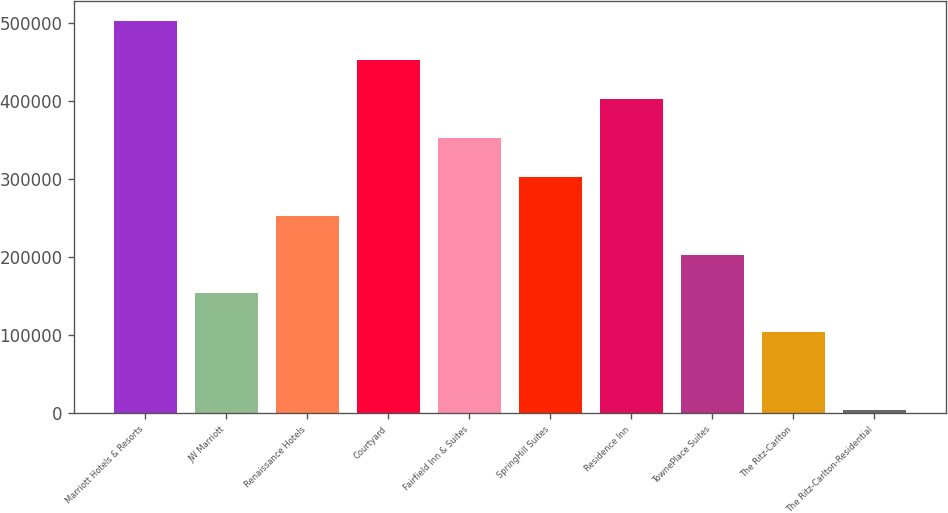Convert chart. <chart><loc_0><loc_0><loc_500><loc_500><bar_chart><fcel>Marriott Hotels & Resorts<fcel>JW Marriott<fcel>Renaissance Hotels<fcel>Courtyard<fcel>Fairfield Inn & Suites<fcel>SpringHill Suites<fcel>Residence Inn<fcel>TownePlace Suites<fcel>The Ritz-Carlton<fcel>The Ritz-Carlton-Residential<nl><fcel>502304<fcel>153148<fcel>252906<fcel>452424<fcel>352666<fcel>302786<fcel>402545<fcel>203027<fcel>103268<fcel>3509<nl></chart> 